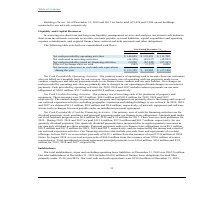From Cogent Communications Group's financial document, What are the respective net cash provided by operating activities in 2017 and 2018? The document shows two values: $ 111,702 and $ 133,921 (in thousands). From the document: "ovided by operating activities $ 148,809 $ 133,921 $ 111,702 Net cash used in investing activities (46,958) (49,937) (45,801) Net cash provided by (us..." Also, What are the respective net cash provided by operating activities in 2018 and 2019? The document shows two values: $ 133,921 and $ 148,809 (in thousands). From the document: "ousands) Net cash provided by operating activities $ 148,809 $ 133,921 $ 111,702 Net cash used in investing activities (46,958) (49,937) (45,801) Net ..." Also, What are the respective net cash used in investing activities in 2017 and 2018? The document shows two values: 45,801 and 49,937 (in thousands). From the document: "2 Net cash used in investing activities (46,958) (49,937) (45,801) Net cash provided by (used in) financing activities 22,020 (52,545) (97,267) Effect..." Also, can you calculate: What is the average net cash provided by operating activities in 2017 and 2018? To answer this question, I need to perform calculations using the financial data. The calculation is: (111,702 + 133,921)/2 , which equals 122811.5 (in thousands). This is based on the information: "cash provided by operating activities $ 148,809 $ 133,921 $ 111,702 Net cash used in investing activities (46,958) (49,937) (45,801) Net cash provided by (us ded by operating activities $ 148,809 $ 13..." The key data points involved are: 111,702, 133,921. Also, can you calculate: What is the average net cash provided by operating activities in 2018 and 2019? To answer this question, I need to perform calculations using the financial data. The calculation is: (133,921 + 148,809)/2 , which equals 141365 (in thousands). This is based on the information: "cash provided by operating activities $ 148,809 $ 133,921 $ 111,702 Net cash used in investing activities (46,958) (49,937) (45,801) Net cash provided by (us ands) Net cash provided by operating activ..." The key data points involved are: 133,921, 148,809. Also, can you calculate: What is the average net cash used in investing activities between 2017 and 2018? To answer this question, I need to perform calculations using the financial data. The calculation is: (45,801 + 49,937)/2 , which equals 47869 (in thousands). This is based on the information: "2 Net cash used in investing activities (46,958) (49,937) (45,801) Net cash provided by (used in) financing activities 22,020 (52,545) (97,267) Effect of ex h used in investing activities (46,958) (49..." The key data points involved are: 45,801, 49,937. 